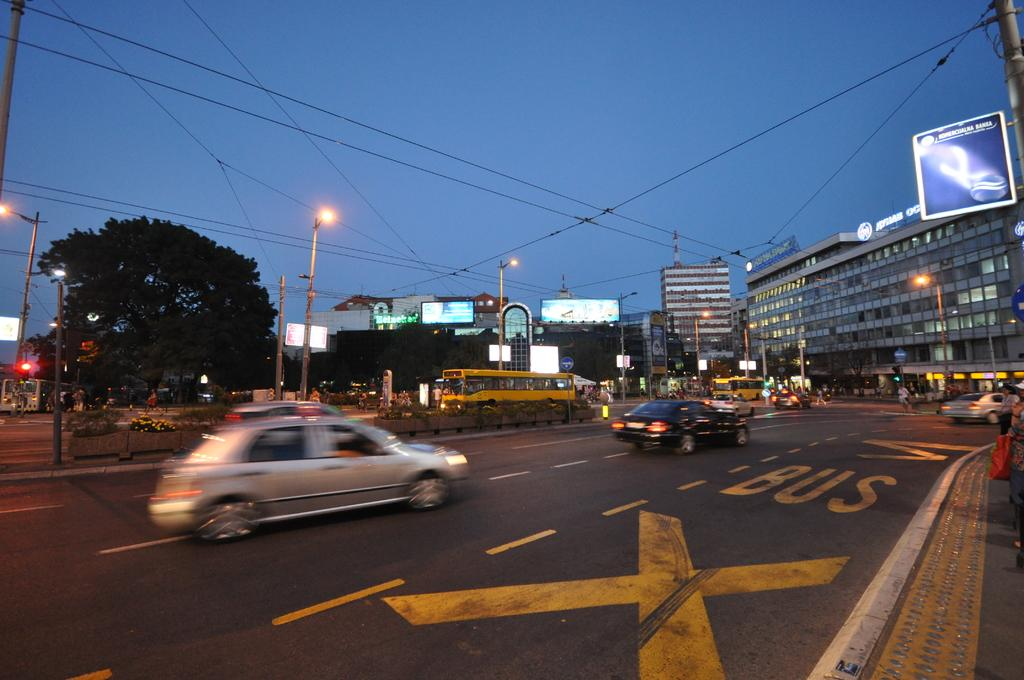<image>
Summarize the visual content of the image. Cars are driving down a street and the word Bus is painted in yellow on the road. 